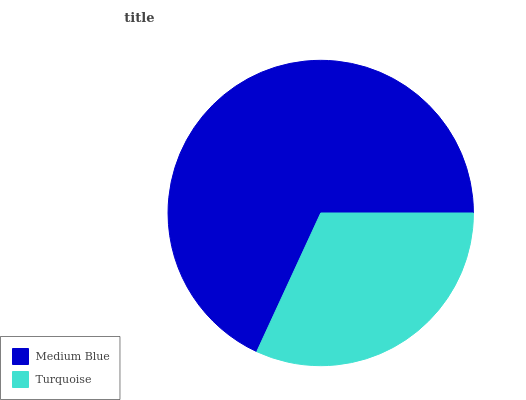Is Turquoise the minimum?
Answer yes or no. Yes. Is Medium Blue the maximum?
Answer yes or no. Yes. Is Turquoise the maximum?
Answer yes or no. No. Is Medium Blue greater than Turquoise?
Answer yes or no. Yes. Is Turquoise less than Medium Blue?
Answer yes or no. Yes. Is Turquoise greater than Medium Blue?
Answer yes or no. No. Is Medium Blue less than Turquoise?
Answer yes or no. No. Is Medium Blue the high median?
Answer yes or no. Yes. Is Turquoise the low median?
Answer yes or no. Yes. Is Turquoise the high median?
Answer yes or no. No. Is Medium Blue the low median?
Answer yes or no. No. 